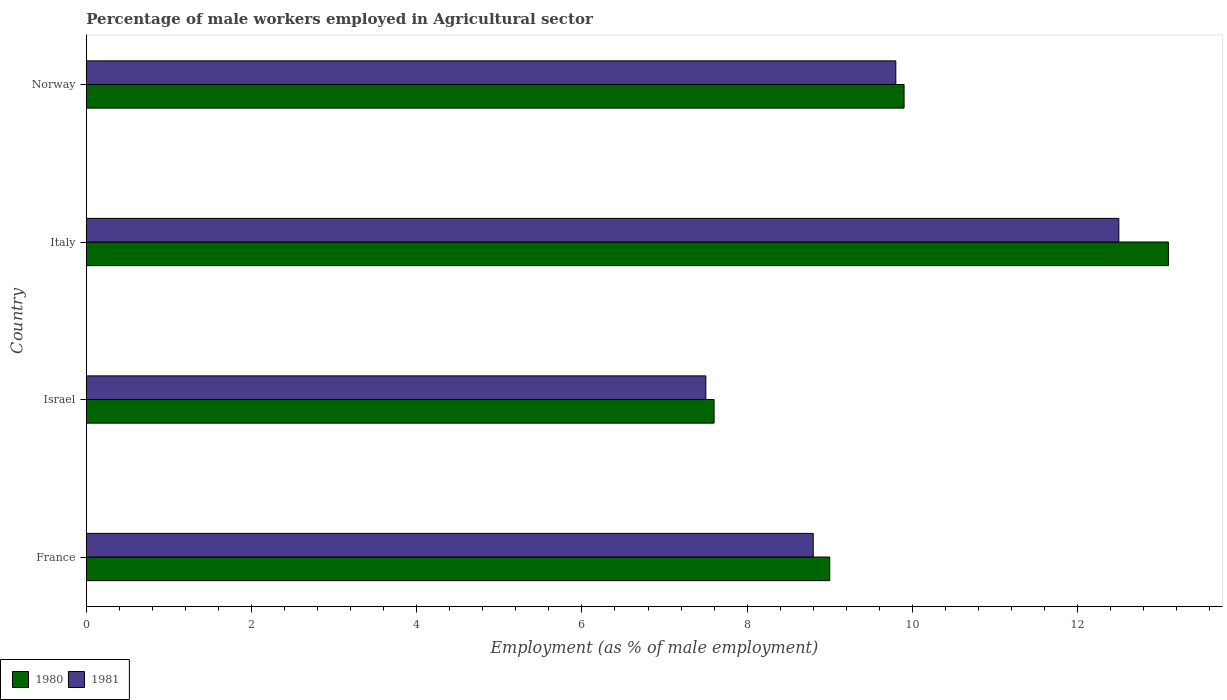How many different coloured bars are there?
Make the answer very short. 2. How many groups of bars are there?
Keep it short and to the point. 4. Are the number of bars per tick equal to the number of legend labels?
Your response must be concise. Yes. How many bars are there on the 3rd tick from the bottom?
Give a very brief answer. 2. What is the percentage of male workers employed in Agricultural sector in 1980 in Italy?
Offer a very short reply. 13.1. Across all countries, what is the minimum percentage of male workers employed in Agricultural sector in 1980?
Your response must be concise. 7.6. In which country was the percentage of male workers employed in Agricultural sector in 1980 maximum?
Offer a very short reply. Italy. What is the total percentage of male workers employed in Agricultural sector in 1981 in the graph?
Provide a succinct answer. 38.6. What is the difference between the percentage of male workers employed in Agricultural sector in 1981 in Israel and that in Italy?
Keep it short and to the point. -5. What is the difference between the percentage of male workers employed in Agricultural sector in 1980 in Italy and the percentage of male workers employed in Agricultural sector in 1981 in France?
Make the answer very short. 4.3. What is the average percentage of male workers employed in Agricultural sector in 1981 per country?
Your response must be concise. 9.65. What is the difference between the percentage of male workers employed in Agricultural sector in 1980 and percentage of male workers employed in Agricultural sector in 1981 in Israel?
Offer a very short reply. 0.1. What is the ratio of the percentage of male workers employed in Agricultural sector in 1980 in France to that in Norway?
Provide a succinct answer. 0.91. Is the percentage of male workers employed in Agricultural sector in 1980 in Italy less than that in Norway?
Make the answer very short. No. Is the difference between the percentage of male workers employed in Agricultural sector in 1980 in France and Norway greater than the difference between the percentage of male workers employed in Agricultural sector in 1981 in France and Norway?
Offer a terse response. Yes. What is the difference between the highest and the second highest percentage of male workers employed in Agricultural sector in 1980?
Ensure brevity in your answer.  3.2. What is the difference between the highest and the lowest percentage of male workers employed in Agricultural sector in 1981?
Keep it short and to the point. 5. In how many countries, is the percentage of male workers employed in Agricultural sector in 1980 greater than the average percentage of male workers employed in Agricultural sector in 1980 taken over all countries?
Give a very brief answer. 1. Is the sum of the percentage of male workers employed in Agricultural sector in 1981 in Israel and Norway greater than the maximum percentage of male workers employed in Agricultural sector in 1980 across all countries?
Provide a succinct answer. Yes. What does the 2nd bar from the top in Italy represents?
Offer a very short reply. 1980. What does the 2nd bar from the bottom in Israel represents?
Offer a terse response. 1981. Are the values on the major ticks of X-axis written in scientific E-notation?
Provide a short and direct response. No. Does the graph contain any zero values?
Give a very brief answer. No. How are the legend labels stacked?
Provide a succinct answer. Horizontal. What is the title of the graph?
Offer a terse response. Percentage of male workers employed in Agricultural sector. What is the label or title of the X-axis?
Your answer should be very brief. Employment (as % of male employment). What is the label or title of the Y-axis?
Provide a short and direct response. Country. What is the Employment (as % of male employment) of 1980 in France?
Your answer should be very brief. 9. What is the Employment (as % of male employment) in 1981 in France?
Offer a terse response. 8.8. What is the Employment (as % of male employment) in 1980 in Israel?
Keep it short and to the point. 7.6. What is the Employment (as % of male employment) in 1981 in Israel?
Keep it short and to the point. 7.5. What is the Employment (as % of male employment) of 1980 in Italy?
Your response must be concise. 13.1. What is the Employment (as % of male employment) of 1981 in Italy?
Your response must be concise. 12.5. What is the Employment (as % of male employment) in 1980 in Norway?
Offer a terse response. 9.9. What is the Employment (as % of male employment) of 1981 in Norway?
Keep it short and to the point. 9.8. Across all countries, what is the maximum Employment (as % of male employment) in 1980?
Give a very brief answer. 13.1. Across all countries, what is the minimum Employment (as % of male employment) of 1980?
Offer a terse response. 7.6. What is the total Employment (as % of male employment) of 1980 in the graph?
Offer a terse response. 39.6. What is the total Employment (as % of male employment) of 1981 in the graph?
Give a very brief answer. 38.6. What is the difference between the Employment (as % of male employment) of 1980 in France and that in Israel?
Your response must be concise. 1.4. What is the difference between the Employment (as % of male employment) in 1981 in France and that in Israel?
Your answer should be very brief. 1.3. What is the difference between the Employment (as % of male employment) of 1981 in France and that in Norway?
Ensure brevity in your answer.  -1. What is the difference between the Employment (as % of male employment) in 1980 in Israel and that in Italy?
Provide a short and direct response. -5.5. What is the difference between the Employment (as % of male employment) of 1981 in Israel and that in Italy?
Provide a short and direct response. -5. What is the difference between the Employment (as % of male employment) in 1980 in Israel and that in Norway?
Make the answer very short. -2.3. What is the difference between the Employment (as % of male employment) in 1980 in Italy and that in Norway?
Your answer should be compact. 3.2. What is the difference between the Employment (as % of male employment) of 1980 in France and the Employment (as % of male employment) of 1981 in Italy?
Your response must be concise. -3.5. What is the difference between the Employment (as % of male employment) of 1980 in France and the Employment (as % of male employment) of 1981 in Norway?
Make the answer very short. -0.8. What is the difference between the Employment (as % of male employment) of 1980 in Israel and the Employment (as % of male employment) of 1981 in Italy?
Give a very brief answer. -4.9. What is the difference between the Employment (as % of male employment) of 1980 in Italy and the Employment (as % of male employment) of 1981 in Norway?
Your answer should be compact. 3.3. What is the average Employment (as % of male employment) of 1981 per country?
Keep it short and to the point. 9.65. What is the difference between the Employment (as % of male employment) in 1980 and Employment (as % of male employment) in 1981 in Israel?
Your answer should be very brief. 0.1. What is the ratio of the Employment (as % of male employment) of 1980 in France to that in Israel?
Your answer should be very brief. 1.18. What is the ratio of the Employment (as % of male employment) of 1981 in France to that in Israel?
Your response must be concise. 1.17. What is the ratio of the Employment (as % of male employment) in 1980 in France to that in Italy?
Provide a short and direct response. 0.69. What is the ratio of the Employment (as % of male employment) in 1981 in France to that in Italy?
Make the answer very short. 0.7. What is the ratio of the Employment (as % of male employment) in 1981 in France to that in Norway?
Make the answer very short. 0.9. What is the ratio of the Employment (as % of male employment) in 1980 in Israel to that in Italy?
Your answer should be compact. 0.58. What is the ratio of the Employment (as % of male employment) of 1980 in Israel to that in Norway?
Ensure brevity in your answer.  0.77. What is the ratio of the Employment (as % of male employment) of 1981 in Israel to that in Norway?
Your answer should be compact. 0.77. What is the ratio of the Employment (as % of male employment) of 1980 in Italy to that in Norway?
Offer a terse response. 1.32. What is the ratio of the Employment (as % of male employment) in 1981 in Italy to that in Norway?
Make the answer very short. 1.28. What is the difference between the highest and the second highest Employment (as % of male employment) of 1981?
Ensure brevity in your answer.  2.7. What is the difference between the highest and the lowest Employment (as % of male employment) of 1980?
Give a very brief answer. 5.5. What is the difference between the highest and the lowest Employment (as % of male employment) of 1981?
Offer a very short reply. 5. 